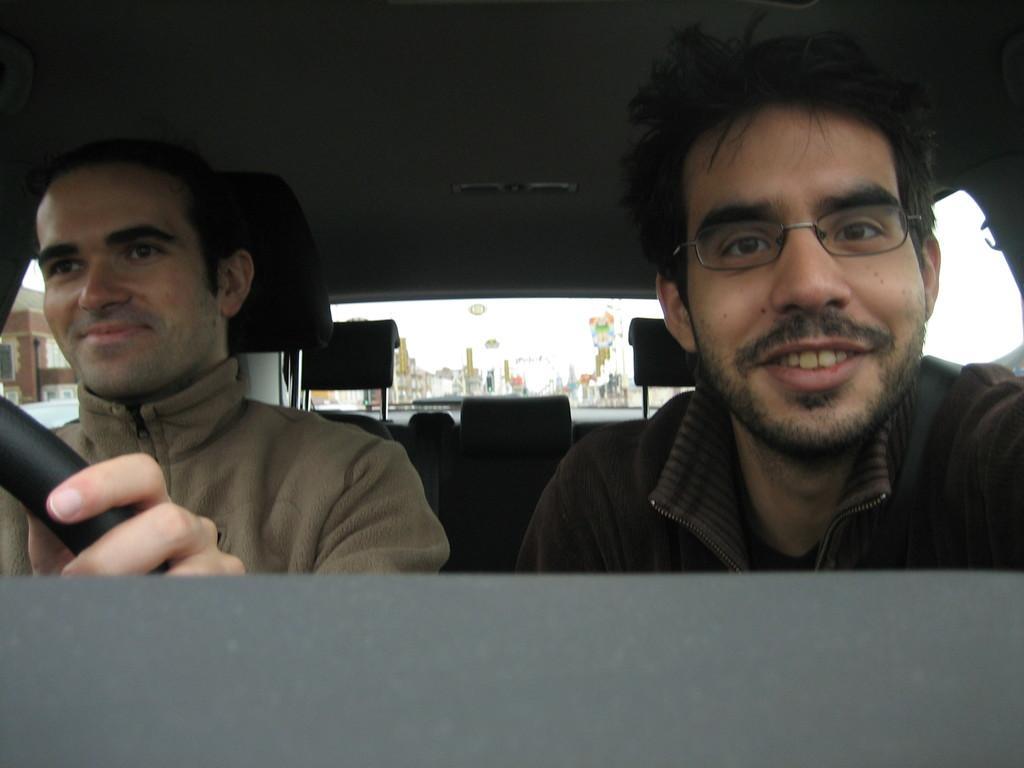Can you describe this image briefly? This image is clicked inside the car. There are two persons in this image. They are men. One is driving a car on the left side. 